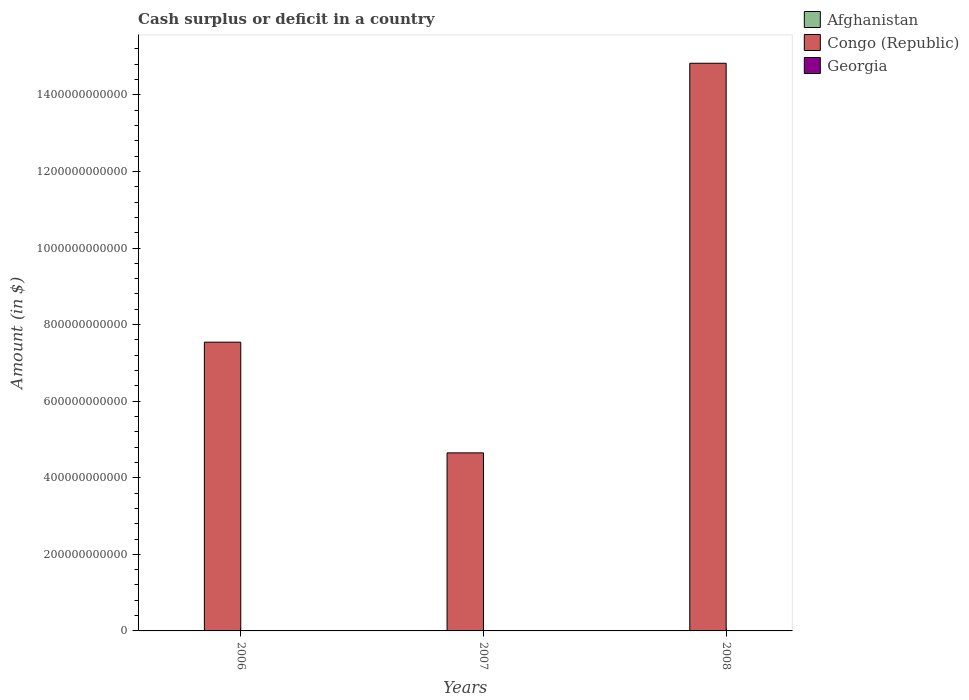Are the number of bars per tick equal to the number of legend labels?
Ensure brevity in your answer.  No. How many bars are there on the 3rd tick from the right?
Provide a succinct answer. 2. In how many cases, is the number of bars for a given year not equal to the number of legend labels?
Offer a terse response. 3. What is the amount of cash surplus or deficit in Georgia in 2006?
Offer a terse response. 2.14e+08. Across all years, what is the maximum amount of cash surplus or deficit in Georgia?
Your answer should be very brief. 2.14e+08. Across all years, what is the minimum amount of cash surplus or deficit in Georgia?
Offer a very short reply. 0. What is the total amount of cash surplus or deficit in Georgia in the graph?
Make the answer very short. 3.44e+08. What is the difference between the amount of cash surplus or deficit in Georgia in 2006 and that in 2007?
Provide a short and direct response. 8.49e+07. What is the difference between the amount of cash surplus or deficit in Congo (Republic) in 2008 and the amount of cash surplus or deficit in Georgia in 2007?
Ensure brevity in your answer.  1.48e+12. What is the average amount of cash surplus or deficit in Georgia per year?
Give a very brief answer. 1.15e+08. In the year 2006, what is the difference between the amount of cash surplus or deficit in Congo (Republic) and amount of cash surplus or deficit in Georgia?
Ensure brevity in your answer.  7.54e+11. What is the ratio of the amount of cash surplus or deficit in Georgia in 2006 to that in 2007?
Your response must be concise. 1.66. Is the amount of cash surplus or deficit in Congo (Republic) in 2007 less than that in 2008?
Give a very brief answer. Yes. What is the difference between the highest and the lowest amount of cash surplus or deficit in Congo (Republic)?
Provide a succinct answer. 1.02e+12. In how many years, is the amount of cash surplus or deficit in Congo (Republic) greater than the average amount of cash surplus or deficit in Congo (Republic) taken over all years?
Give a very brief answer. 1. How many bars are there?
Provide a succinct answer. 5. How many years are there in the graph?
Offer a very short reply. 3. What is the difference between two consecutive major ticks on the Y-axis?
Your answer should be compact. 2.00e+11. Are the values on the major ticks of Y-axis written in scientific E-notation?
Give a very brief answer. No. Does the graph contain grids?
Ensure brevity in your answer.  No. Where does the legend appear in the graph?
Offer a terse response. Top right. How many legend labels are there?
Your answer should be very brief. 3. What is the title of the graph?
Ensure brevity in your answer.  Cash surplus or deficit in a country. Does "St. Kitts and Nevis" appear as one of the legend labels in the graph?
Provide a short and direct response. No. What is the label or title of the Y-axis?
Ensure brevity in your answer.  Amount (in $). What is the Amount (in $) of Congo (Republic) in 2006?
Your response must be concise. 7.54e+11. What is the Amount (in $) of Georgia in 2006?
Ensure brevity in your answer.  2.14e+08. What is the Amount (in $) of Congo (Republic) in 2007?
Ensure brevity in your answer.  4.65e+11. What is the Amount (in $) in Georgia in 2007?
Offer a terse response. 1.30e+08. What is the Amount (in $) of Afghanistan in 2008?
Make the answer very short. 0. What is the Amount (in $) of Congo (Republic) in 2008?
Your answer should be very brief. 1.48e+12. Across all years, what is the maximum Amount (in $) of Congo (Republic)?
Your answer should be very brief. 1.48e+12. Across all years, what is the maximum Amount (in $) in Georgia?
Provide a succinct answer. 2.14e+08. Across all years, what is the minimum Amount (in $) of Congo (Republic)?
Ensure brevity in your answer.  4.65e+11. Across all years, what is the minimum Amount (in $) of Georgia?
Provide a short and direct response. 0. What is the total Amount (in $) in Congo (Republic) in the graph?
Provide a succinct answer. 2.70e+12. What is the total Amount (in $) of Georgia in the graph?
Offer a terse response. 3.44e+08. What is the difference between the Amount (in $) of Congo (Republic) in 2006 and that in 2007?
Offer a terse response. 2.89e+11. What is the difference between the Amount (in $) of Georgia in 2006 and that in 2007?
Offer a terse response. 8.49e+07. What is the difference between the Amount (in $) of Congo (Republic) in 2006 and that in 2008?
Give a very brief answer. -7.28e+11. What is the difference between the Amount (in $) of Congo (Republic) in 2007 and that in 2008?
Provide a short and direct response. -1.02e+12. What is the difference between the Amount (in $) in Congo (Republic) in 2006 and the Amount (in $) in Georgia in 2007?
Offer a terse response. 7.54e+11. What is the average Amount (in $) of Congo (Republic) per year?
Offer a terse response. 9.01e+11. What is the average Amount (in $) of Georgia per year?
Offer a terse response. 1.15e+08. In the year 2006, what is the difference between the Amount (in $) of Congo (Republic) and Amount (in $) of Georgia?
Your response must be concise. 7.54e+11. In the year 2007, what is the difference between the Amount (in $) of Congo (Republic) and Amount (in $) of Georgia?
Give a very brief answer. 4.65e+11. What is the ratio of the Amount (in $) of Congo (Republic) in 2006 to that in 2007?
Your response must be concise. 1.62. What is the ratio of the Amount (in $) of Georgia in 2006 to that in 2007?
Give a very brief answer. 1.66. What is the ratio of the Amount (in $) in Congo (Republic) in 2006 to that in 2008?
Provide a succinct answer. 0.51. What is the ratio of the Amount (in $) in Congo (Republic) in 2007 to that in 2008?
Make the answer very short. 0.31. What is the difference between the highest and the second highest Amount (in $) in Congo (Republic)?
Your answer should be compact. 7.28e+11. What is the difference between the highest and the lowest Amount (in $) in Congo (Republic)?
Your answer should be compact. 1.02e+12. What is the difference between the highest and the lowest Amount (in $) of Georgia?
Give a very brief answer. 2.14e+08. 